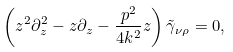<formula> <loc_0><loc_0><loc_500><loc_500>\left ( z ^ { 2 } \partial _ { z } ^ { 2 } - z \partial _ { z } - \frac { p ^ { 2 } } { 4 k ^ { 2 } } z \right ) \tilde { \gamma } _ { \nu \rho } = 0 ,</formula> 